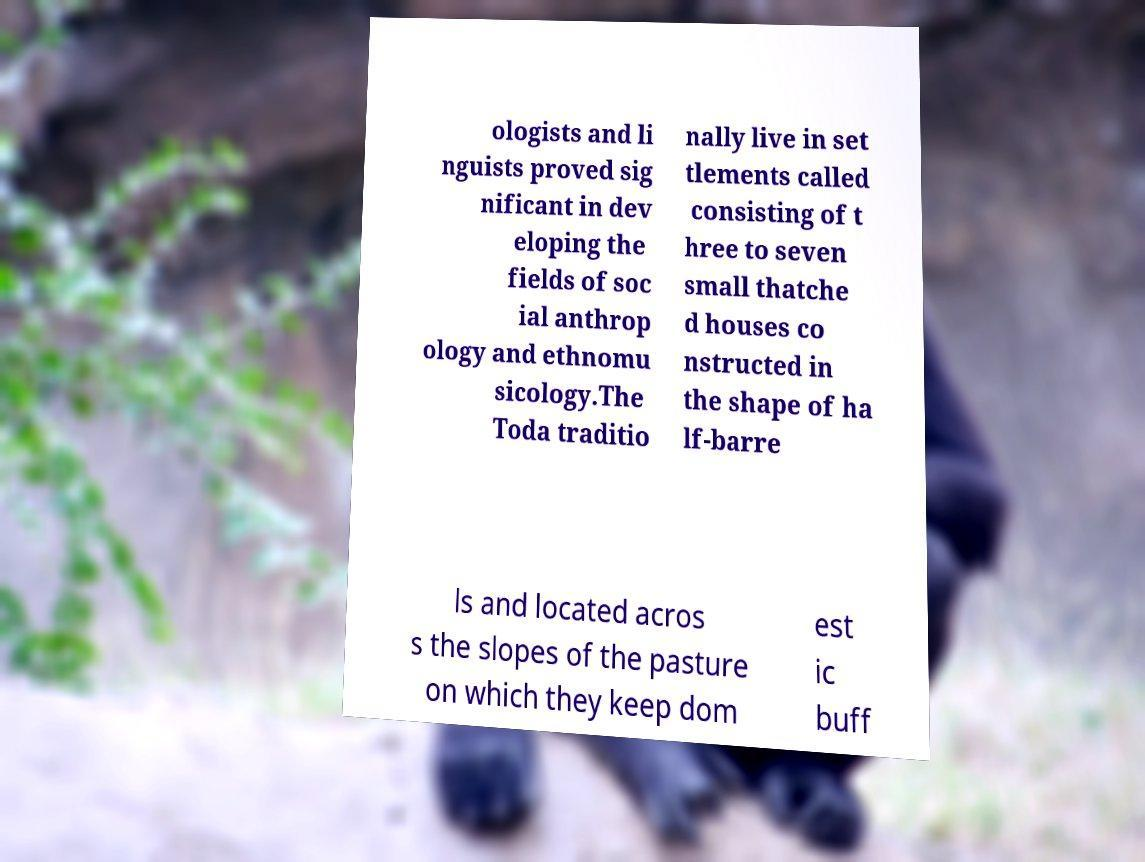For documentation purposes, I need the text within this image transcribed. Could you provide that? ologists and li nguists proved sig nificant in dev eloping the fields of soc ial anthrop ology and ethnomu sicology.The Toda traditio nally live in set tlements called consisting of t hree to seven small thatche d houses co nstructed in the shape of ha lf-barre ls and located acros s the slopes of the pasture on which they keep dom est ic buff 